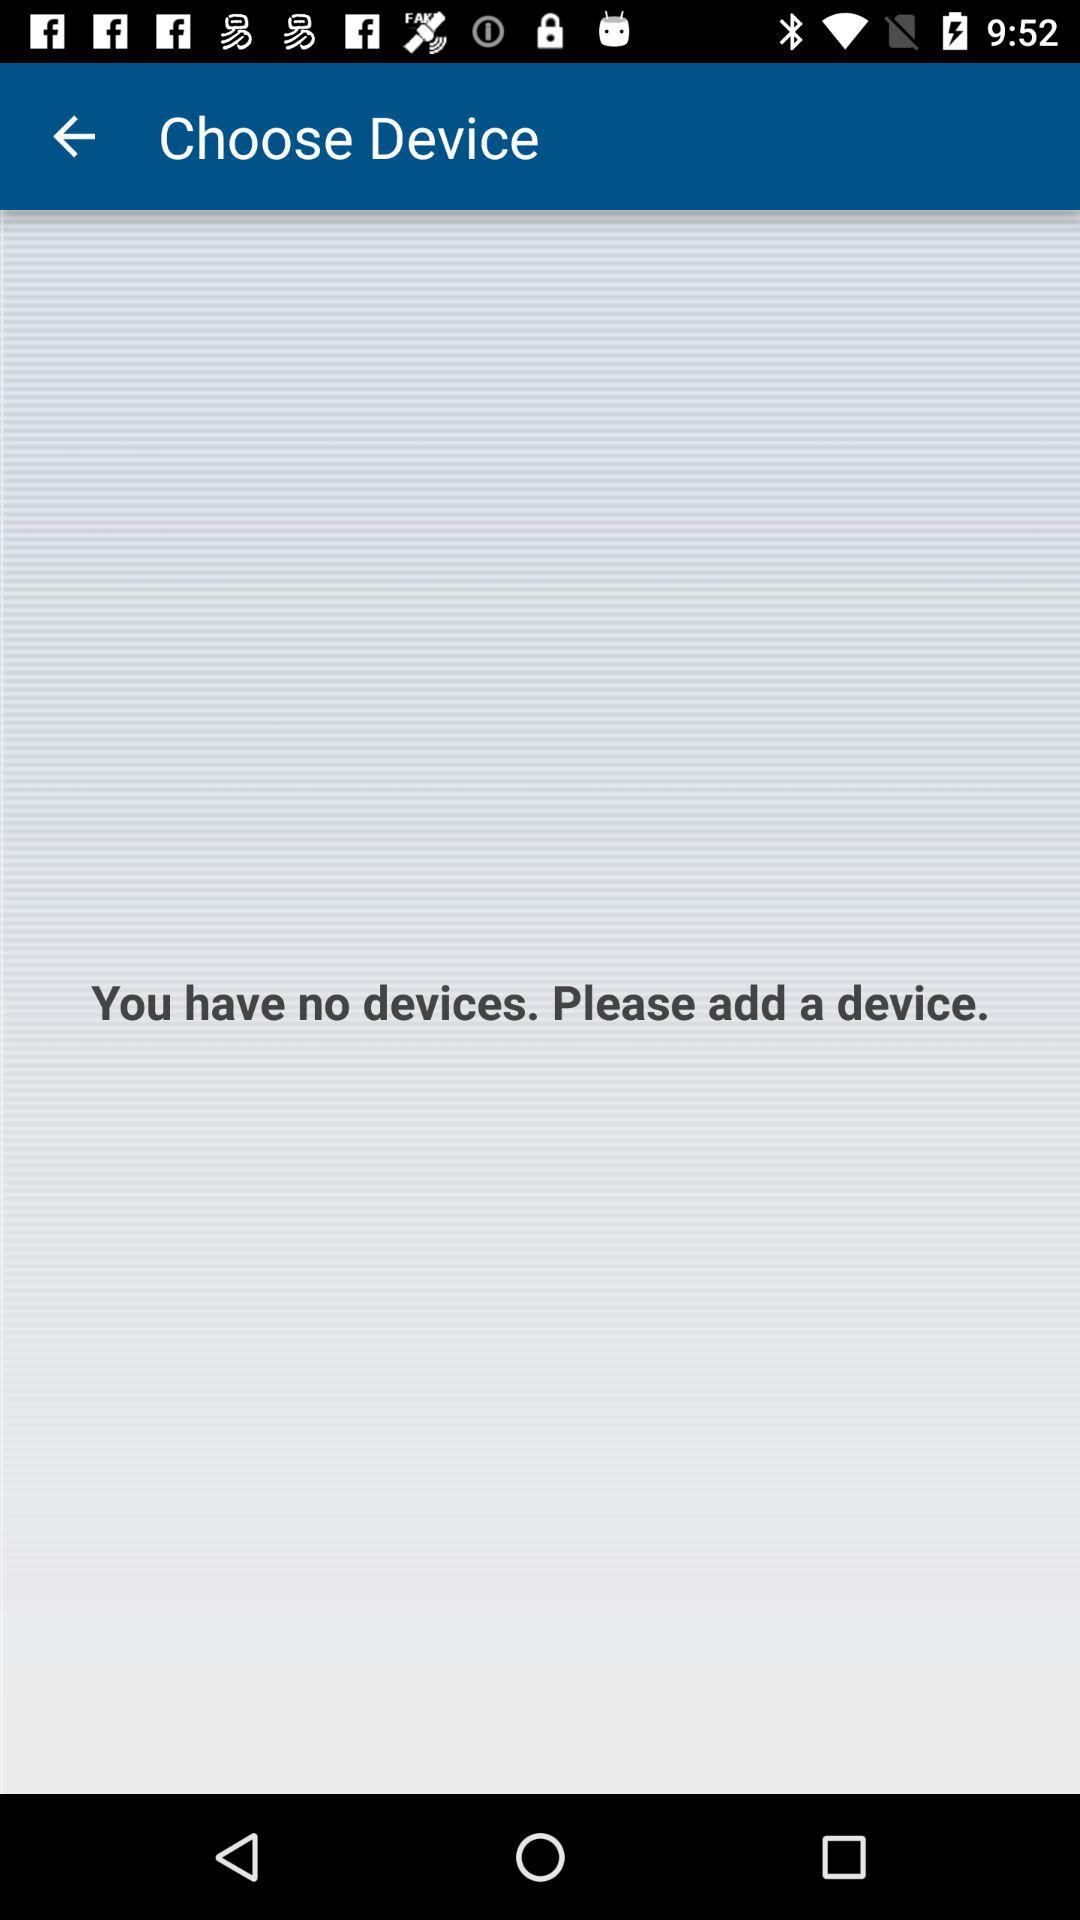How many devices are connected?
Answer the question using a single word or phrase. 0 